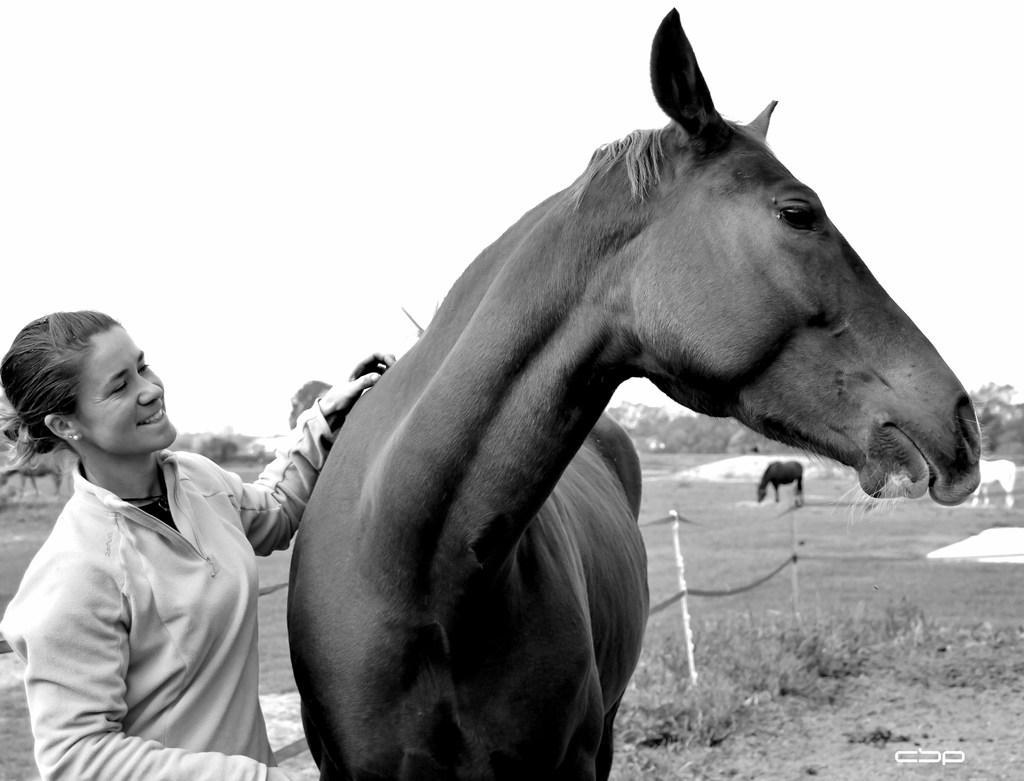Please provide a concise description of this image. In this image I can see a woman standing and a horse in the garden. 